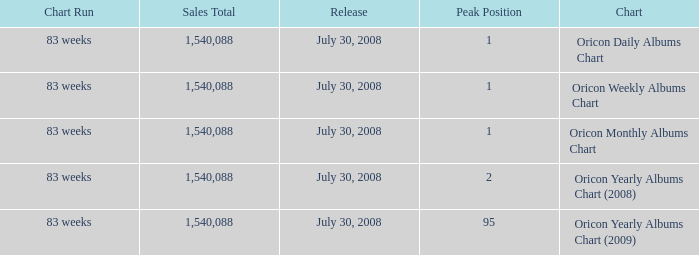Which Sales Total has a Chart of oricon monthly albums chart? 1540088.0. 